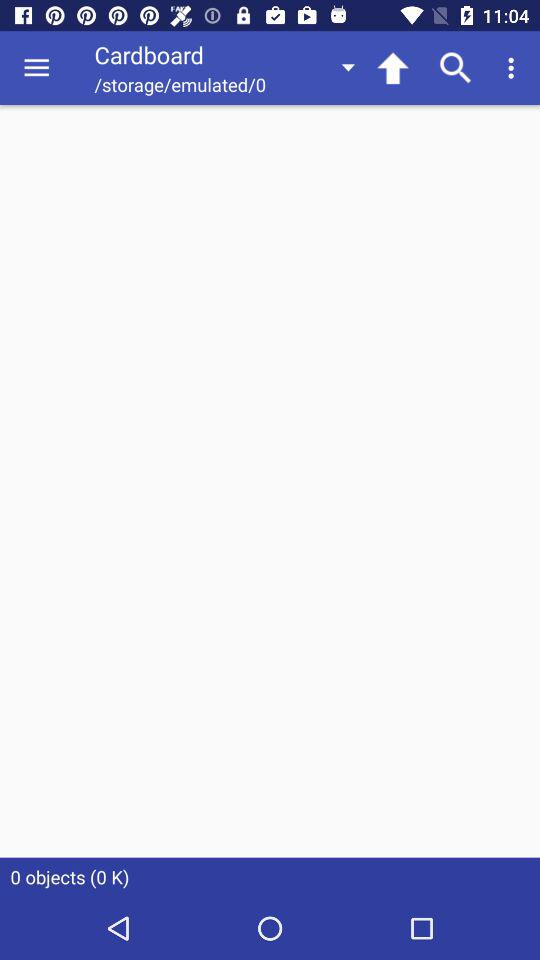How many objects are in the folder?
Answer the question using a single word or phrase. 0 